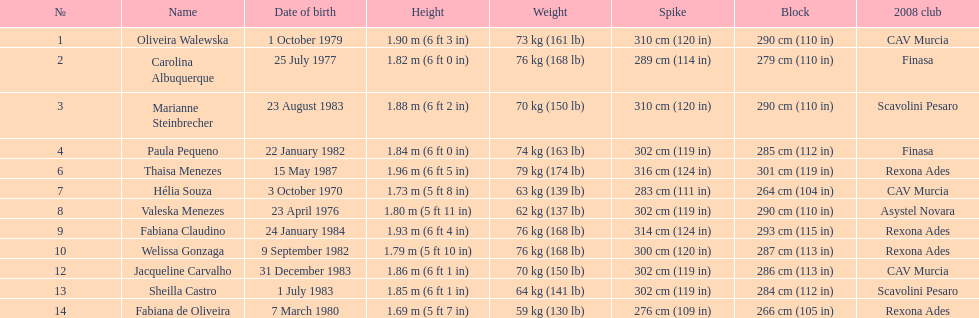Which athlete is the smallest at just 5 ft 7 in? Fabiana de Oliveira. 